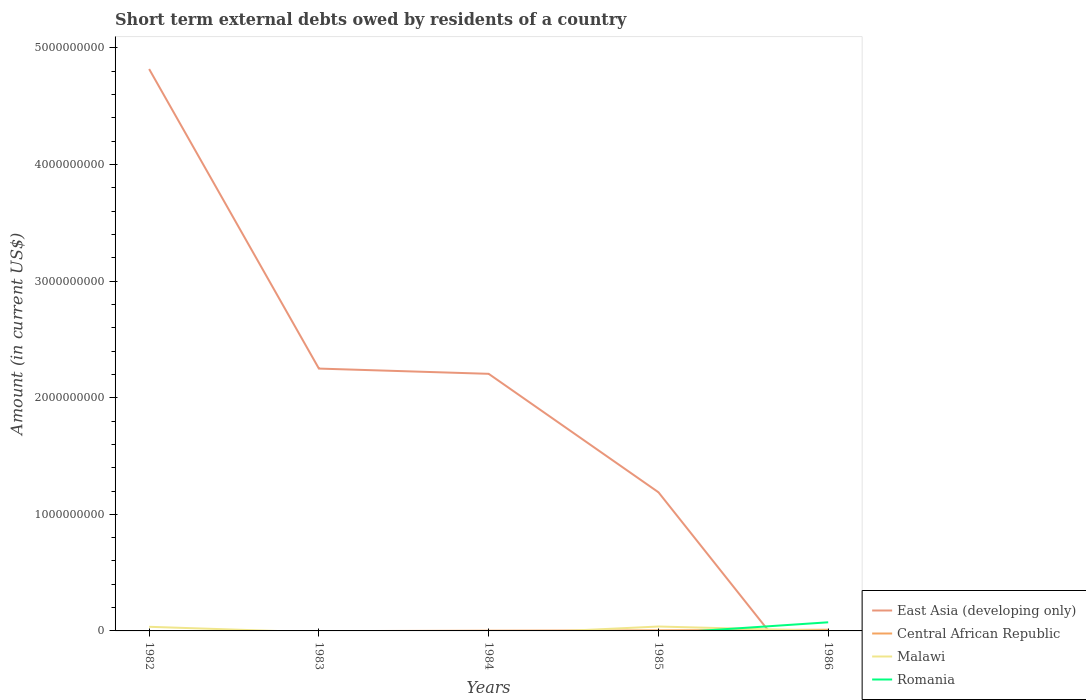How many different coloured lines are there?
Provide a succinct answer. 4. Does the line corresponding to Malawi intersect with the line corresponding to East Asia (developing only)?
Your answer should be compact. Yes. Across all years, what is the maximum amount of short-term external debts owed by residents in Romania?
Keep it short and to the point. 0. What is the total amount of short-term external debts owed by residents in East Asia (developing only) in the graph?
Keep it short and to the point. 1.06e+09. What is the difference between the highest and the second highest amount of short-term external debts owed by residents in Central African Republic?
Provide a short and direct response. 1.00e+07. Are the values on the major ticks of Y-axis written in scientific E-notation?
Make the answer very short. No. Does the graph contain any zero values?
Your answer should be very brief. Yes. Where does the legend appear in the graph?
Offer a very short reply. Bottom right. How many legend labels are there?
Your response must be concise. 4. How are the legend labels stacked?
Provide a short and direct response. Vertical. What is the title of the graph?
Offer a terse response. Short term external debts owed by residents of a country. What is the label or title of the X-axis?
Make the answer very short. Years. What is the Amount (in current US$) in East Asia (developing only) in 1982?
Your answer should be very brief. 4.82e+09. What is the Amount (in current US$) in Malawi in 1982?
Offer a terse response. 3.54e+07. What is the Amount (in current US$) of Romania in 1982?
Offer a terse response. 0. What is the Amount (in current US$) in East Asia (developing only) in 1983?
Provide a short and direct response. 2.25e+09. What is the Amount (in current US$) in East Asia (developing only) in 1984?
Keep it short and to the point. 2.20e+09. What is the Amount (in current US$) in Central African Republic in 1984?
Provide a short and direct response. 2.00e+06. What is the Amount (in current US$) of Malawi in 1984?
Make the answer very short. 0. What is the Amount (in current US$) of Romania in 1984?
Ensure brevity in your answer.  0. What is the Amount (in current US$) of East Asia (developing only) in 1985?
Ensure brevity in your answer.  1.19e+09. What is the Amount (in current US$) in Malawi in 1985?
Ensure brevity in your answer.  3.78e+07. What is the Amount (in current US$) in East Asia (developing only) in 1986?
Give a very brief answer. 0. What is the Amount (in current US$) of Central African Republic in 1986?
Ensure brevity in your answer.  1.00e+07. What is the Amount (in current US$) in Malawi in 1986?
Keep it short and to the point. 2.25e+05. What is the Amount (in current US$) of Romania in 1986?
Ensure brevity in your answer.  7.40e+07. Across all years, what is the maximum Amount (in current US$) of East Asia (developing only)?
Your answer should be very brief. 4.82e+09. Across all years, what is the maximum Amount (in current US$) in Malawi?
Give a very brief answer. 3.78e+07. Across all years, what is the maximum Amount (in current US$) in Romania?
Offer a terse response. 7.40e+07. Across all years, what is the minimum Amount (in current US$) in Central African Republic?
Provide a short and direct response. 0. Across all years, what is the minimum Amount (in current US$) of Malawi?
Offer a very short reply. 0. Across all years, what is the minimum Amount (in current US$) in Romania?
Ensure brevity in your answer.  0. What is the total Amount (in current US$) of East Asia (developing only) in the graph?
Offer a terse response. 1.05e+1. What is the total Amount (in current US$) of Central African Republic in the graph?
Keep it short and to the point. 1.70e+07. What is the total Amount (in current US$) in Malawi in the graph?
Ensure brevity in your answer.  7.34e+07. What is the total Amount (in current US$) of Romania in the graph?
Provide a short and direct response. 7.40e+07. What is the difference between the Amount (in current US$) in East Asia (developing only) in 1982 and that in 1983?
Offer a very short reply. 2.57e+09. What is the difference between the Amount (in current US$) of East Asia (developing only) in 1982 and that in 1984?
Give a very brief answer. 2.61e+09. What is the difference between the Amount (in current US$) in East Asia (developing only) in 1982 and that in 1985?
Ensure brevity in your answer.  3.63e+09. What is the difference between the Amount (in current US$) in Malawi in 1982 and that in 1985?
Offer a terse response. -2.44e+06. What is the difference between the Amount (in current US$) in Malawi in 1982 and that in 1986?
Your response must be concise. 3.52e+07. What is the difference between the Amount (in current US$) in East Asia (developing only) in 1983 and that in 1984?
Ensure brevity in your answer.  4.50e+07. What is the difference between the Amount (in current US$) in East Asia (developing only) in 1983 and that in 1985?
Offer a very short reply. 1.06e+09. What is the difference between the Amount (in current US$) of East Asia (developing only) in 1984 and that in 1985?
Make the answer very short. 1.02e+09. What is the difference between the Amount (in current US$) of Central African Republic in 1984 and that in 1985?
Make the answer very short. -3.00e+06. What is the difference between the Amount (in current US$) in Central African Republic in 1984 and that in 1986?
Give a very brief answer. -8.00e+06. What is the difference between the Amount (in current US$) of Central African Republic in 1985 and that in 1986?
Provide a succinct answer. -5.00e+06. What is the difference between the Amount (in current US$) in Malawi in 1985 and that in 1986?
Keep it short and to the point. 3.76e+07. What is the difference between the Amount (in current US$) of East Asia (developing only) in 1982 and the Amount (in current US$) of Central African Republic in 1984?
Keep it short and to the point. 4.82e+09. What is the difference between the Amount (in current US$) in East Asia (developing only) in 1982 and the Amount (in current US$) in Central African Republic in 1985?
Provide a short and direct response. 4.81e+09. What is the difference between the Amount (in current US$) in East Asia (developing only) in 1982 and the Amount (in current US$) in Malawi in 1985?
Your answer should be very brief. 4.78e+09. What is the difference between the Amount (in current US$) of East Asia (developing only) in 1982 and the Amount (in current US$) of Central African Republic in 1986?
Ensure brevity in your answer.  4.81e+09. What is the difference between the Amount (in current US$) in East Asia (developing only) in 1982 and the Amount (in current US$) in Malawi in 1986?
Your answer should be compact. 4.82e+09. What is the difference between the Amount (in current US$) in East Asia (developing only) in 1982 and the Amount (in current US$) in Romania in 1986?
Provide a succinct answer. 4.74e+09. What is the difference between the Amount (in current US$) in Malawi in 1982 and the Amount (in current US$) in Romania in 1986?
Ensure brevity in your answer.  -3.86e+07. What is the difference between the Amount (in current US$) of East Asia (developing only) in 1983 and the Amount (in current US$) of Central African Republic in 1984?
Offer a very short reply. 2.25e+09. What is the difference between the Amount (in current US$) in East Asia (developing only) in 1983 and the Amount (in current US$) in Central African Republic in 1985?
Your response must be concise. 2.24e+09. What is the difference between the Amount (in current US$) in East Asia (developing only) in 1983 and the Amount (in current US$) in Malawi in 1985?
Offer a terse response. 2.21e+09. What is the difference between the Amount (in current US$) in East Asia (developing only) in 1983 and the Amount (in current US$) in Central African Republic in 1986?
Provide a short and direct response. 2.24e+09. What is the difference between the Amount (in current US$) of East Asia (developing only) in 1983 and the Amount (in current US$) of Malawi in 1986?
Give a very brief answer. 2.25e+09. What is the difference between the Amount (in current US$) in East Asia (developing only) in 1983 and the Amount (in current US$) in Romania in 1986?
Your answer should be compact. 2.18e+09. What is the difference between the Amount (in current US$) in East Asia (developing only) in 1984 and the Amount (in current US$) in Central African Republic in 1985?
Provide a short and direct response. 2.20e+09. What is the difference between the Amount (in current US$) of East Asia (developing only) in 1984 and the Amount (in current US$) of Malawi in 1985?
Give a very brief answer. 2.17e+09. What is the difference between the Amount (in current US$) of Central African Republic in 1984 and the Amount (in current US$) of Malawi in 1985?
Offer a terse response. -3.58e+07. What is the difference between the Amount (in current US$) in East Asia (developing only) in 1984 and the Amount (in current US$) in Central African Republic in 1986?
Your answer should be very brief. 2.20e+09. What is the difference between the Amount (in current US$) in East Asia (developing only) in 1984 and the Amount (in current US$) in Malawi in 1986?
Offer a terse response. 2.20e+09. What is the difference between the Amount (in current US$) of East Asia (developing only) in 1984 and the Amount (in current US$) of Romania in 1986?
Ensure brevity in your answer.  2.13e+09. What is the difference between the Amount (in current US$) in Central African Republic in 1984 and the Amount (in current US$) in Malawi in 1986?
Keep it short and to the point. 1.78e+06. What is the difference between the Amount (in current US$) in Central African Republic in 1984 and the Amount (in current US$) in Romania in 1986?
Ensure brevity in your answer.  -7.20e+07. What is the difference between the Amount (in current US$) in East Asia (developing only) in 1985 and the Amount (in current US$) in Central African Republic in 1986?
Provide a succinct answer. 1.18e+09. What is the difference between the Amount (in current US$) in East Asia (developing only) in 1985 and the Amount (in current US$) in Malawi in 1986?
Give a very brief answer. 1.19e+09. What is the difference between the Amount (in current US$) in East Asia (developing only) in 1985 and the Amount (in current US$) in Romania in 1986?
Keep it short and to the point. 1.12e+09. What is the difference between the Amount (in current US$) of Central African Republic in 1985 and the Amount (in current US$) of Malawi in 1986?
Ensure brevity in your answer.  4.78e+06. What is the difference between the Amount (in current US$) in Central African Republic in 1985 and the Amount (in current US$) in Romania in 1986?
Offer a terse response. -6.90e+07. What is the difference between the Amount (in current US$) of Malawi in 1985 and the Amount (in current US$) of Romania in 1986?
Ensure brevity in your answer.  -3.62e+07. What is the average Amount (in current US$) in East Asia (developing only) per year?
Your answer should be compact. 2.09e+09. What is the average Amount (in current US$) of Central African Republic per year?
Provide a short and direct response. 3.40e+06. What is the average Amount (in current US$) of Malawi per year?
Keep it short and to the point. 1.47e+07. What is the average Amount (in current US$) in Romania per year?
Provide a short and direct response. 1.48e+07. In the year 1982, what is the difference between the Amount (in current US$) in East Asia (developing only) and Amount (in current US$) in Malawi?
Keep it short and to the point. 4.78e+09. In the year 1984, what is the difference between the Amount (in current US$) in East Asia (developing only) and Amount (in current US$) in Central African Republic?
Keep it short and to the point. 2.20e+09. In the year 1985, what is the difference between the Amount (in current US$) in East Asia (developing only) and Amount (in current US$) in Central African Republic?
Provide a short and direct response. 1.18e+09. In the year 1985, what is the difference between the Amount (in current US$) of East Asia (developing only) and Amount (in current US$) of Malawi?
Offer a terse response. 1.15e+09. In the year 1985, what is the difference between the Amount (in current US$) in Central African Republic and Amount (in current US$) in Malawi?
Provide a succinct answer. -3.28e+07. In the year 1986, what is the difference between the Amount (in current US$) in Central African Republic and Amount (in current US$) in Malawi?
Make the answer very short. 9.78e+06. In the year 1986, what is the difference between the Amount (in current US$) of Central African Republic and Amount (in current US$) of Romania?
Your response must be concise. -6.40e+07. In the year 1986, what is the difference between the Amount (in current US$) in Malawi and Amount (in current US$) in Romania?
Your answer should be very brief. -7.38e+07. What is the ratio of the Amount (in current US$) of East Asia (developing only) in 1982 to that in 1983?
Offer a very short reply. 2.14. What is the ratio of the Amount (in current US$) in East Asia (developing only) in 1982 to that in 1984?
Your response must be concise. 2.19. What is the ratio of the Amount (in current US$) of East Asia (developing only) in 1982 to that in 1985?
Ensure brevity in your answer.  4.05. What is the ratio of the Amount (in current US$) in Malawi in 1982 to that in 1985?
Ensure brevity in your answer.  0.94. What is the ratio of the Amount (in current US$) of Malawi in 1982 to that in 1986?
Provide a short and direct response. 157.24. What is the ratio of the Amount (in current US$) of East Asia (developing only) in 1983 to that in 1984?
Make the answer very short. 1.02. What is the ratio of the Amount (in current US$) in East Asia (developing only) in 1983 to that in 1985?
Ensure brevity in your answer.  1.89. What is the ratio of the Amount (in current US$) in East Asia (developing only) in 1984 to that in 1985?
Make the answer very short. 1.85. What is the ratio of the Amount (in current US$) of Central African Republic in 1984 to that in 1986?
Give a very brief answer. 0.2. What is the ratio of the Amount (in current US$) of Central African Republic in 1985 to that in 1986?
Give a very brief answer. 0.5. What is the ratio of the Amount (in current US$) in Malawi in 1985 to that in 1986?
Make the answer very short. 168.1. What is the difference between the highest and the second highest Amount (in current US$) in East Asia (developing only)?
Your response must be concise. 2.57e+09. What is the difference between the highest and the second highest Amount (in current US$) in Malawi?
Your answer should be very brief. 2.44e+06. What is the difference between the highest and the lowest Amount (in current US$) in East Asia (developing only)?
Your answer should be compact. 4.82e+09. What is the difference between the highest and the lowest Amount (in current US$) in Malawi?
Provide a succinct answer. 3.78e+07. What is the difference between the highest and the lowest Amount (in current US$) of Romania?
Your answer should be very brief. 7.40e+07. 